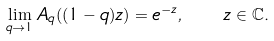Convert formula to latex. <formula><loc_0><loc_0><loc_500><loc_500>\lim _ { q \to 1 } A _ { q } ( ( 1 - q ) z ) = e ^ { - z } , \quad z \in \mathbb { C } .</formula> 